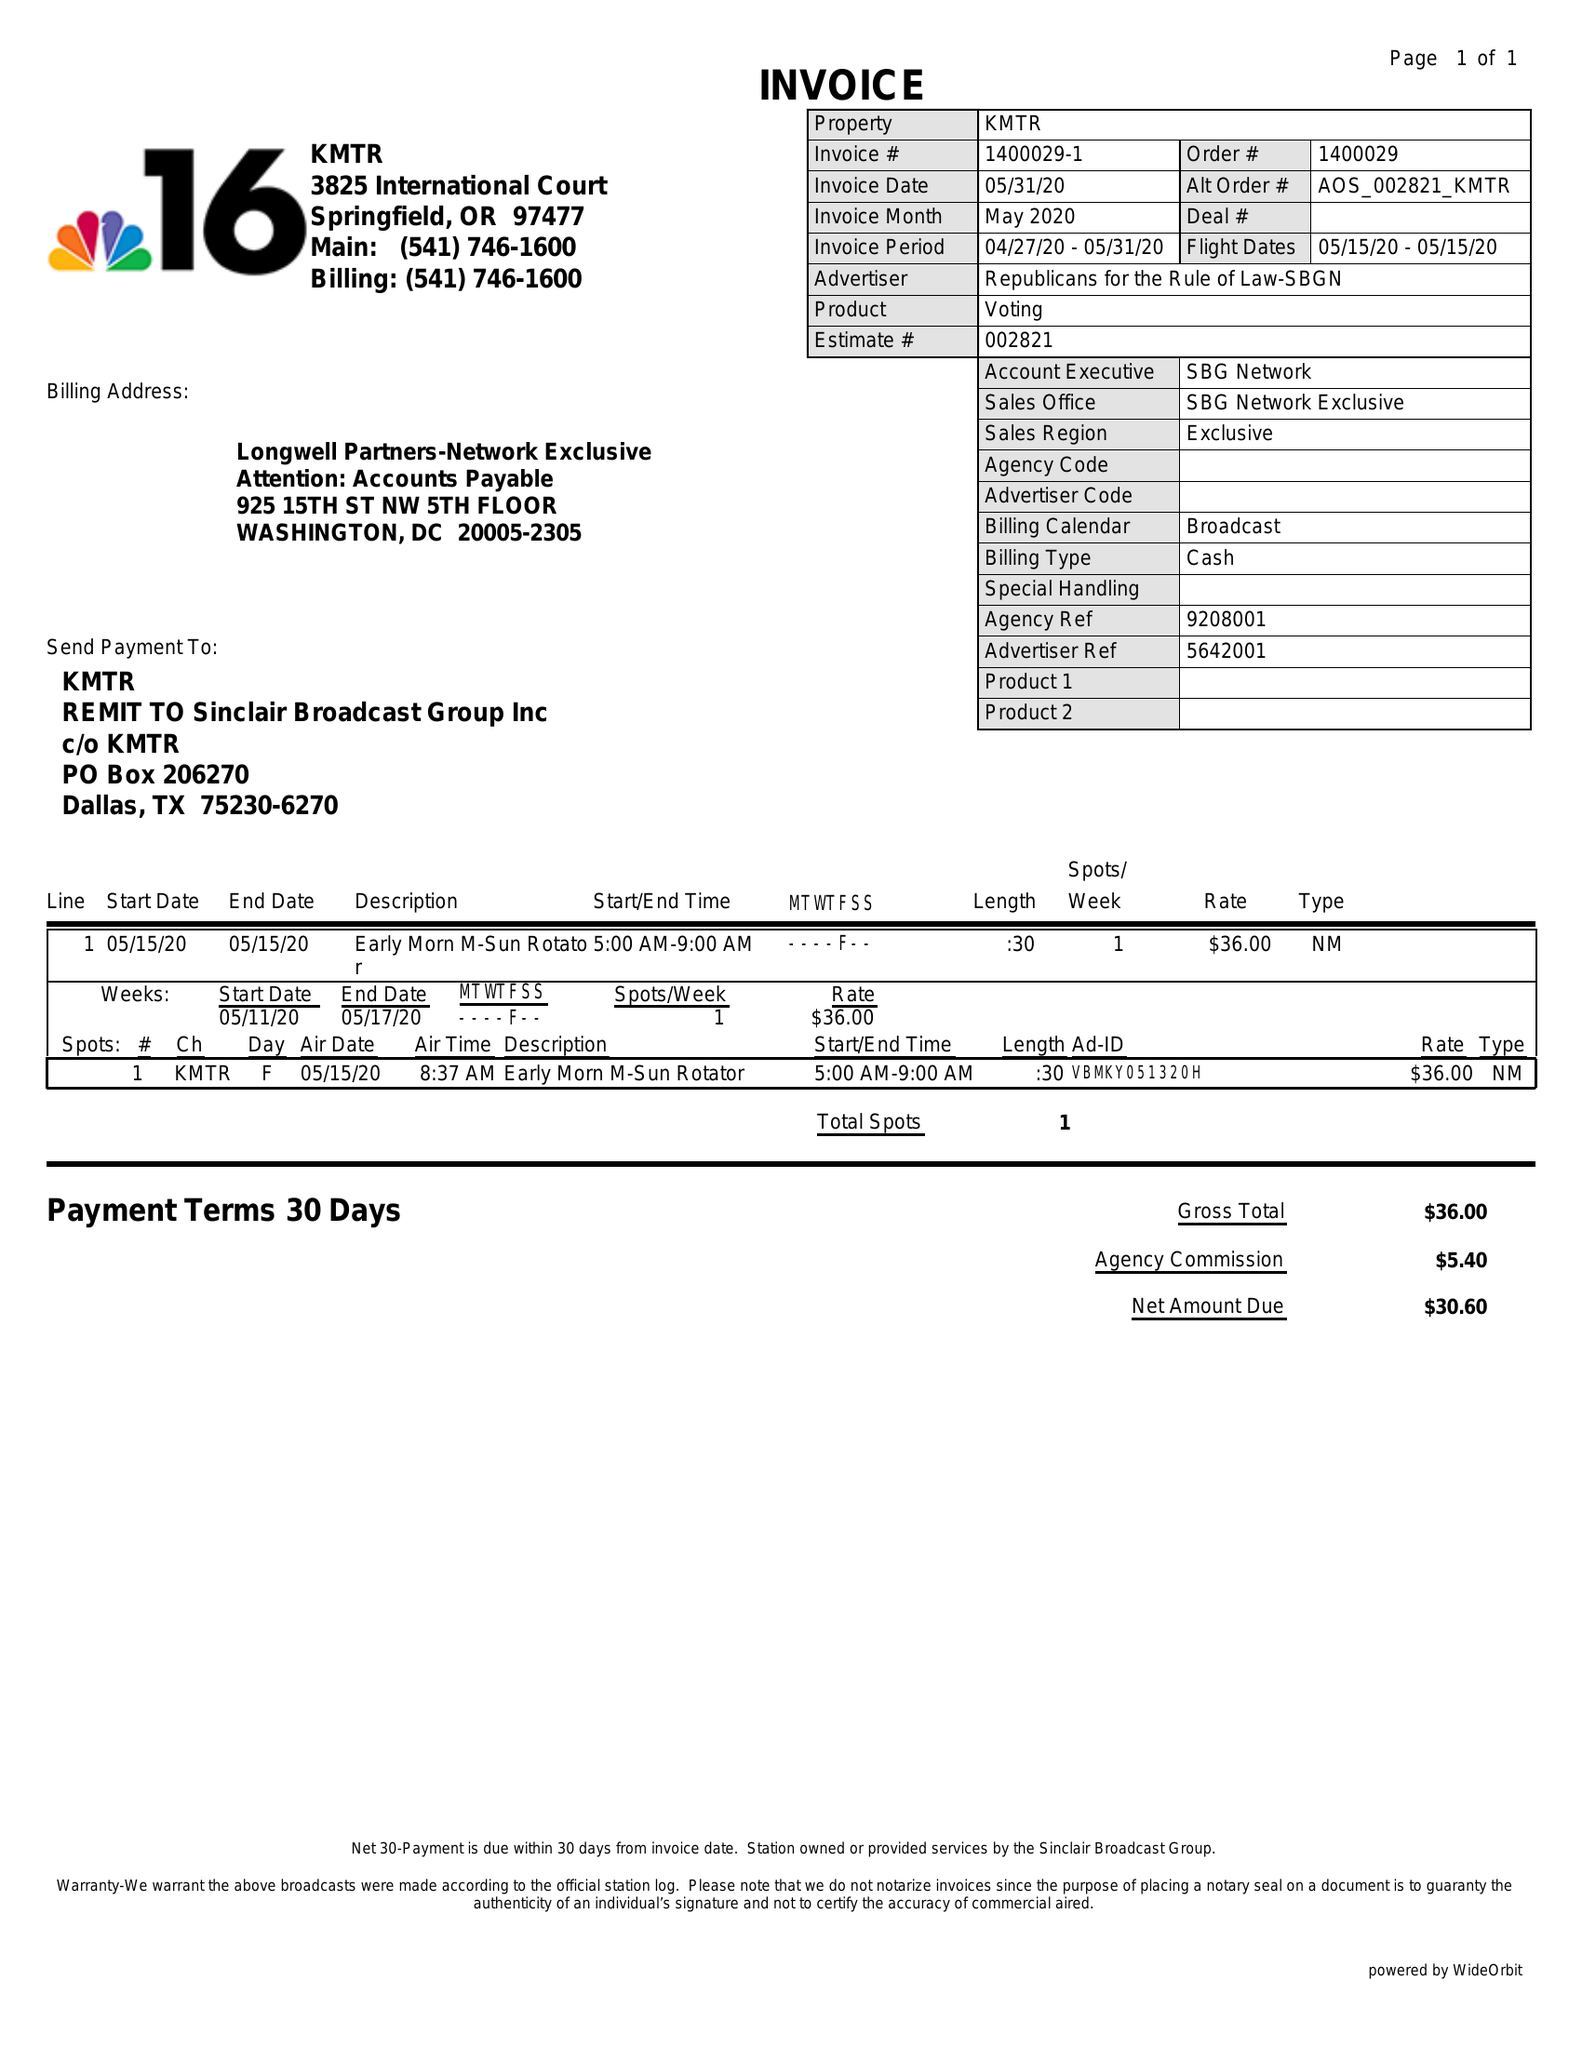What is the value for the advertiser?
Answer the question using a single word or phrase. REPUBLICANS FOR THE RULE OF LAW-SBGN 